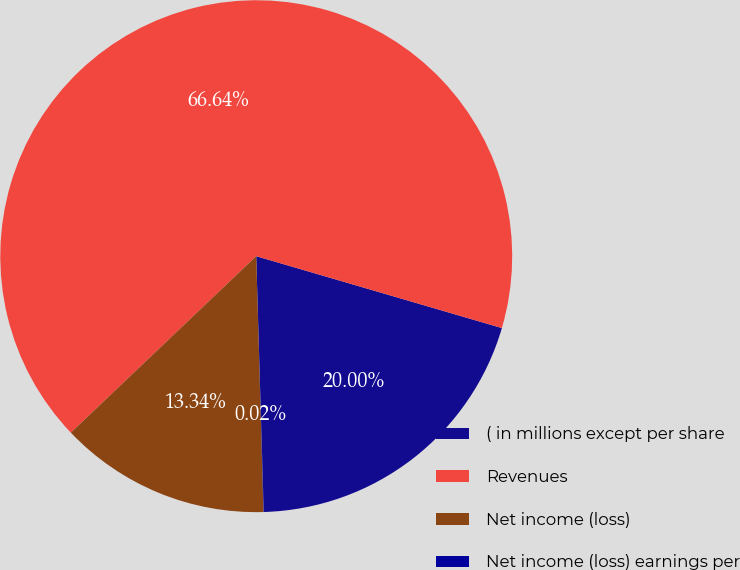Convert chart. <chart><loc_0><loc_0><loc_500><loc_500><pie_chart><fcel>( in millions except per share<fcel>Revenues<fcel>Net income (loss)<fcel>Net income (loss) earnings per<nl><fcel>20.0%<fcel>66.64%<fcel>13.34%<fcel>0.02%<nl></chart> 